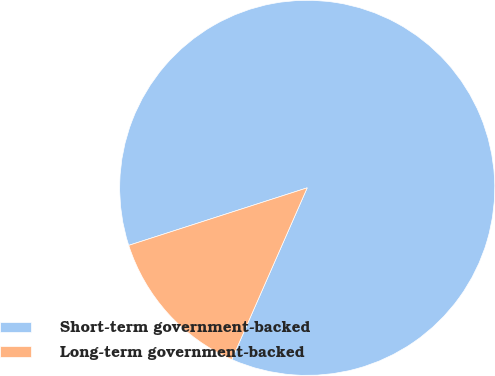Convert chart to OTSL. <chart><loc_0><loc_0><loc_500><loc_500><pie_chart><fcel>Short-term government-backed<fcel>Long-term government-backed<nl><fcel>86.55%<fcel>13.45%<nl></chart> 